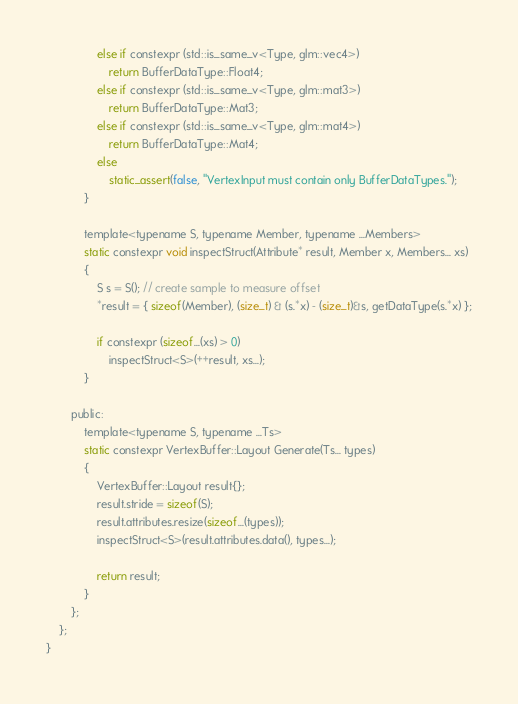<code> <loc_0><loc_0><loc_500><loc_500><_C_>				else if constexpr (std::is_same_v<Type, glm::vec4>)
					return BufferDataType::Float4;
				else if constexpr (std::is_same_v<Type, glm::mat3>)
					return BufferDataType::Mat3;
				else if constexpr (std::is_same_v<Type, glm::mat4>)
					return BufferDataType::Mat4;
				else
					static_assert(false, "VertexInput must contain only BufferDataTypes.");
			}

			template<typename S, typename Member, typename ...Members>
			static constexpr void inspectStruct(Attribute* result, Member x, Members... xs)
			{
				S s = S(); // create sample to measure offset
				*result = { sizeof(Member), (size_t) & (s.*x) - (size_t)&s, getDataType(s.*x) };

				if constexpr (sizeof...(xs) > 0)
					inspectStruct<S>(++result, xs...);
			}

		public:
			template<typename S, typename ...Ts>
			static constexpr VertexBuffer::Layout Generate(Ts... types)
			{
				VertexBuffer::Layout result{};
				result.stride = sizeof(S);
				result.attributes.resize(sizeof...(types));
				inspectStruct<S>(result.attributes.data(), types...);

				return result;
			}
		};
	};
}</code> 